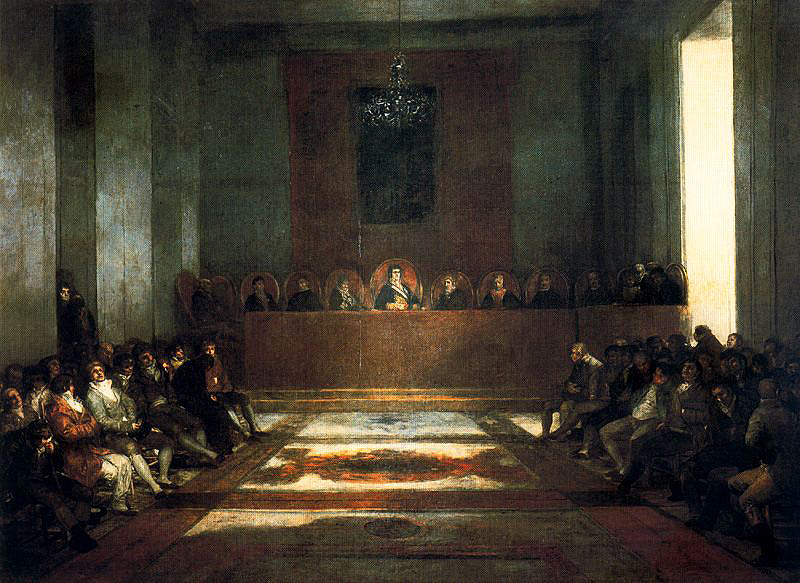Who might be the central figure in this painting, and what significance do they hold in this assembly? The central figure, seated slightly elevated in the midst of distinguished individuals, likely represents a high-ranking religious or spiritual leader. This person's pivotal position and the focused attention of the audience emphasize their significance, possibly delivering a sermon or key decision vital to the community's spiritual or social fabric. 